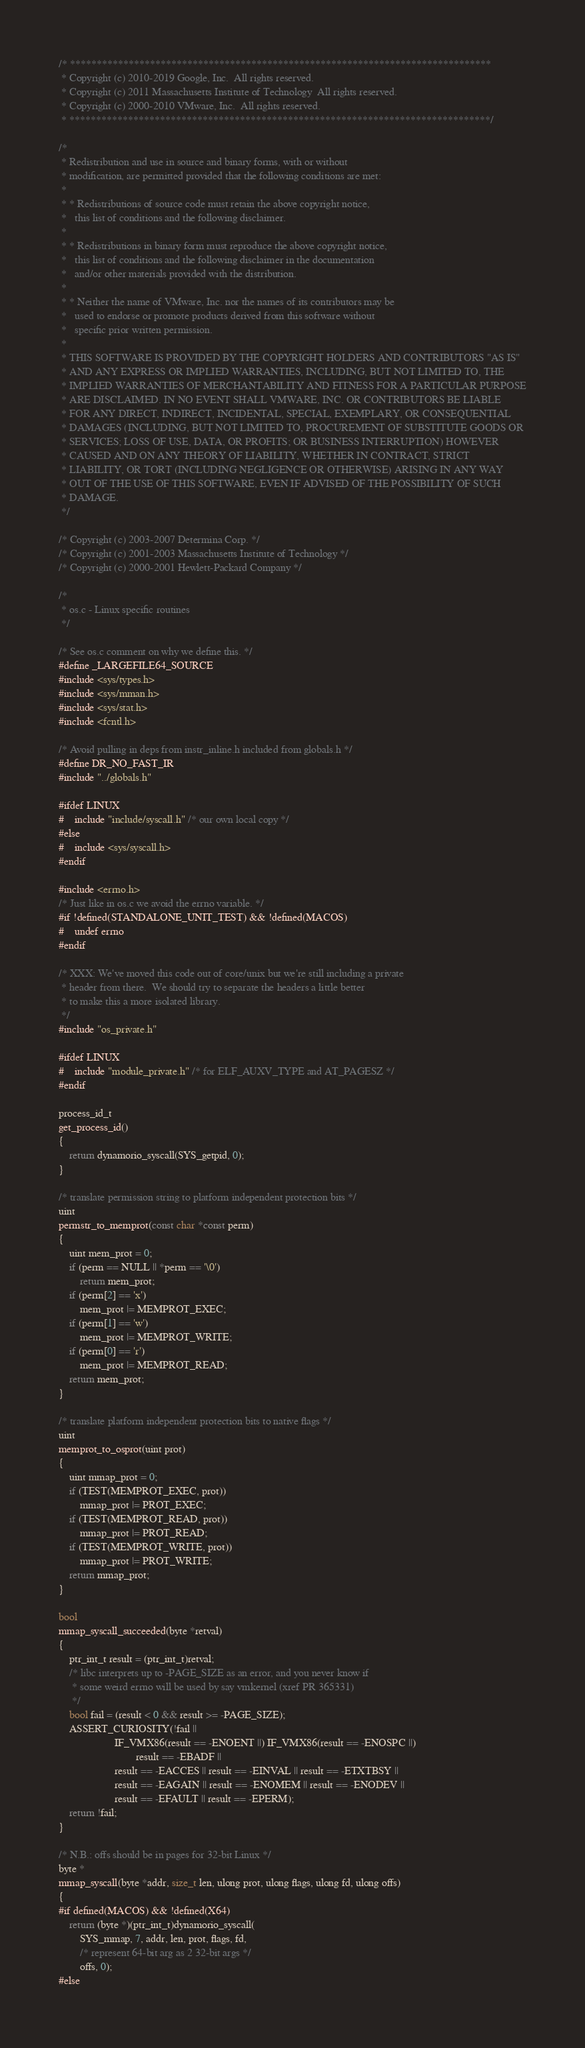Convert code to text. <code><loc_0><loc_0><loc_500><loc_500><_C_>/* *******************************************************************************
 * Copyright (c) 2010-2019 Google, Inc.  All rights reserved.
 * Copyright (c) 2011 Massachusetts Institute of Technology  All rights reserved.
 * Copyright (c) 2000-2010 VMware, Inc.  All rights reserved.
 * *******************************************************************************/

/*
 * Redistribution and use in source and binary forms, with or without
 * modification, are permitted provided that the following conditions are met:
 *
 * * Redistributions of source code must retain the above copyright notice,
 *   this list of conditions and the following disclaimer.
 *
 * * Redistributions in binary form must reproduce the above copyright notice,
 *   this list of conditions and the following disclaimer in the documentation
 *   and/or other materials provided with the distribution.
 *
 * * Neither the name of VMware, Inc. nor the names of its contributors may be
 *   used to endorse or promote products derived from this software without
 *   specific prior written permission.
 *
 * THIS SOFTWARE IS PROVIDED BY THE COPYRIGHT HOLDERS AND CONTRIBUTORS "AS IS"
 * AND ANY EXPRESS OR IMPLIED WARRANTIES, INCLUDING, BUT NOT LIMITED TO, THE
 * IMPLIED WARRANTIES OF MERCHANTABILITY AND FITNESS FOR A PARTICULAR PURPOSE
 * ARE DISCLAIMED. IN NO EVENT SHALL VMWARE, INC. OR CONTRIBUTORS BE LIABLE
 * FOR ANY DIRECT, INDIRECT, INCIDENTAL, SPECIAL, EXEMPLARY, OR CONSEQUENTIAL
 * DAMAGES (INCLUDING, BUT NOT LIMITED TO, PROCUREMENT OF SUBSTITUTE GOODS OR
 * SERVICES; LOSS OF USE, DATA, OR PROFITS; OR BUSINESS INTERRUPTION) HOWEVER
 * CAUSED AND ON ANY THEORY OF LIABILITY, WHETHER IN CONTRACT, STRICT
 * LIABILITY, OR TORT (INCLUDING NEGLIGENCE OR OTHERWISE) ARISING IN ANY WAY
 * OUT OF THE USE OF THIS SOFTWARE, EVEN IF ADVISED OF THE POSSIBILITY OF SUCH
 * DAMAGE.
 */

/* Copyright (c) 2003-2007 Determina Corp. */
/* Copyright (c) 2001-2003 Massachusetts Institute of Technology */
/* Copyright (c) 2000-2001 Hewlett-Packard Company */

/*
 * os.c - Linux specific routines
 */

/* See os.c comment on why we define this. */
#define _LARGEFILE64_SOURCE
#include <sys/types.h>
#include <sys/mman.h>
#include <sys/stat.h>
#include <fcntl.h>

/* Avoid pulling in deps from instr_inline.h included from globals.h */
#define DR_NO_FAST_IR
#include "../globals.h"

#ifdef LINUX
#    include "include/syscall.h" /* our own local copy */
#else
#    include <sys/syscall.h>
#endif

#include <errno.h>
/* Just like in os.c we avoid the errno variable. */
#if !defined(STANDALONE_UNIT_TEST) && !defined(MACOS)
#    undef errno
#endif

/* XXX: We've moved this code out of core/unix but we're still including a private
 * header from there.  We should try to separate the headers a little better
 * to make this a more isolated library.
 */
#include "os_private.h"

#ifdef LINUX
#    include "module_private.h" /* for ELF_AUXV_TYPE and AT_PAGESZ */
#endif

process_id_t
get_process_id()
{
    return dynamorio_syscall(SYS_getpid, 0);
}

/* translate permission string to platform independent protection bits */
uint
permstr_to_memprot(const char *const perm)
{
    uint mem_prot = 0;
    if (perm == NULL || *perm == '\0')
        return mem_prot;
    if (perm[2] == 'x')
        mem_prot |= MEMPROT_EXEC;
    if (perm[1] == 'w')
        mem_prot |= MEMPROT_WRITE;
    if (perm[0] == 'r')
        mem_prot |= MEMPROT_READ;
    return mem_prot;
}

/* translate platform independent protection bits to native flags */
uint
memprot_to_osprot(uint prot)
{
    uint mmap_prot = 0;
    if (TEST(MEMPROT_EXEC, prot))
        mmap_prot |= PROT_EXEC;
    if (TEST(MEMPROT_READ, prot))
        mmap_prot |= PROT_READ;
    if (TEST(MEMPROT_WRITE, prot))
        mmap_prot |= PROT_WRITE;
    return mmap_prot;
}

bool
mmap_syscall_succeeded(byte *retval)
{
    ptr_int_t result = (ptr_int_t)retval;
    /* libc interprets up to -PAGE_SIZE as an error, and you never know if
     * some weird errno will be used by say vmkernel (xref PR 365331)
     */
    bool fail = (result < 0 && result >= -PAGE_SIZE);
    ASSERT_CURIOSITY(!fail ||
                     IF_VMX86(result == -ENOENT ||) IF_VMX86(result == -ENOSPC ||)
                             result == -EBADF ||
                     result == -EACCES || result == -EINVAL || result == -ETXTBSY ||
                     result == -EAGAIN || result == -ENOMEM || result == -ENODEV ||
                     result == -EFAULT || result == -EPERM);
    return !fail;
}

/* N.B.: offs should be in pages for 32-bit Linux */
byte *
mmap_syscall(byte *addr, size_t len, ulong prot, ulong flags, ulong fd, ulong offs)
{
#if defined(MACOS) && !defined(X64)
    return (byte *)(ptr_int_t)dynamorio_syscall(
        SYS_mmap, 7, addr, len, prot, flags, fd,
        /* represent 64-bit arg as 2 32-bit args */
        offs, 0);
#else</code> 